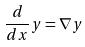Convert formula to latex. <formula><loc_0><loc_0><loc_500><loc_500>\frac { d } { d x } y = \nabla y</formula> 